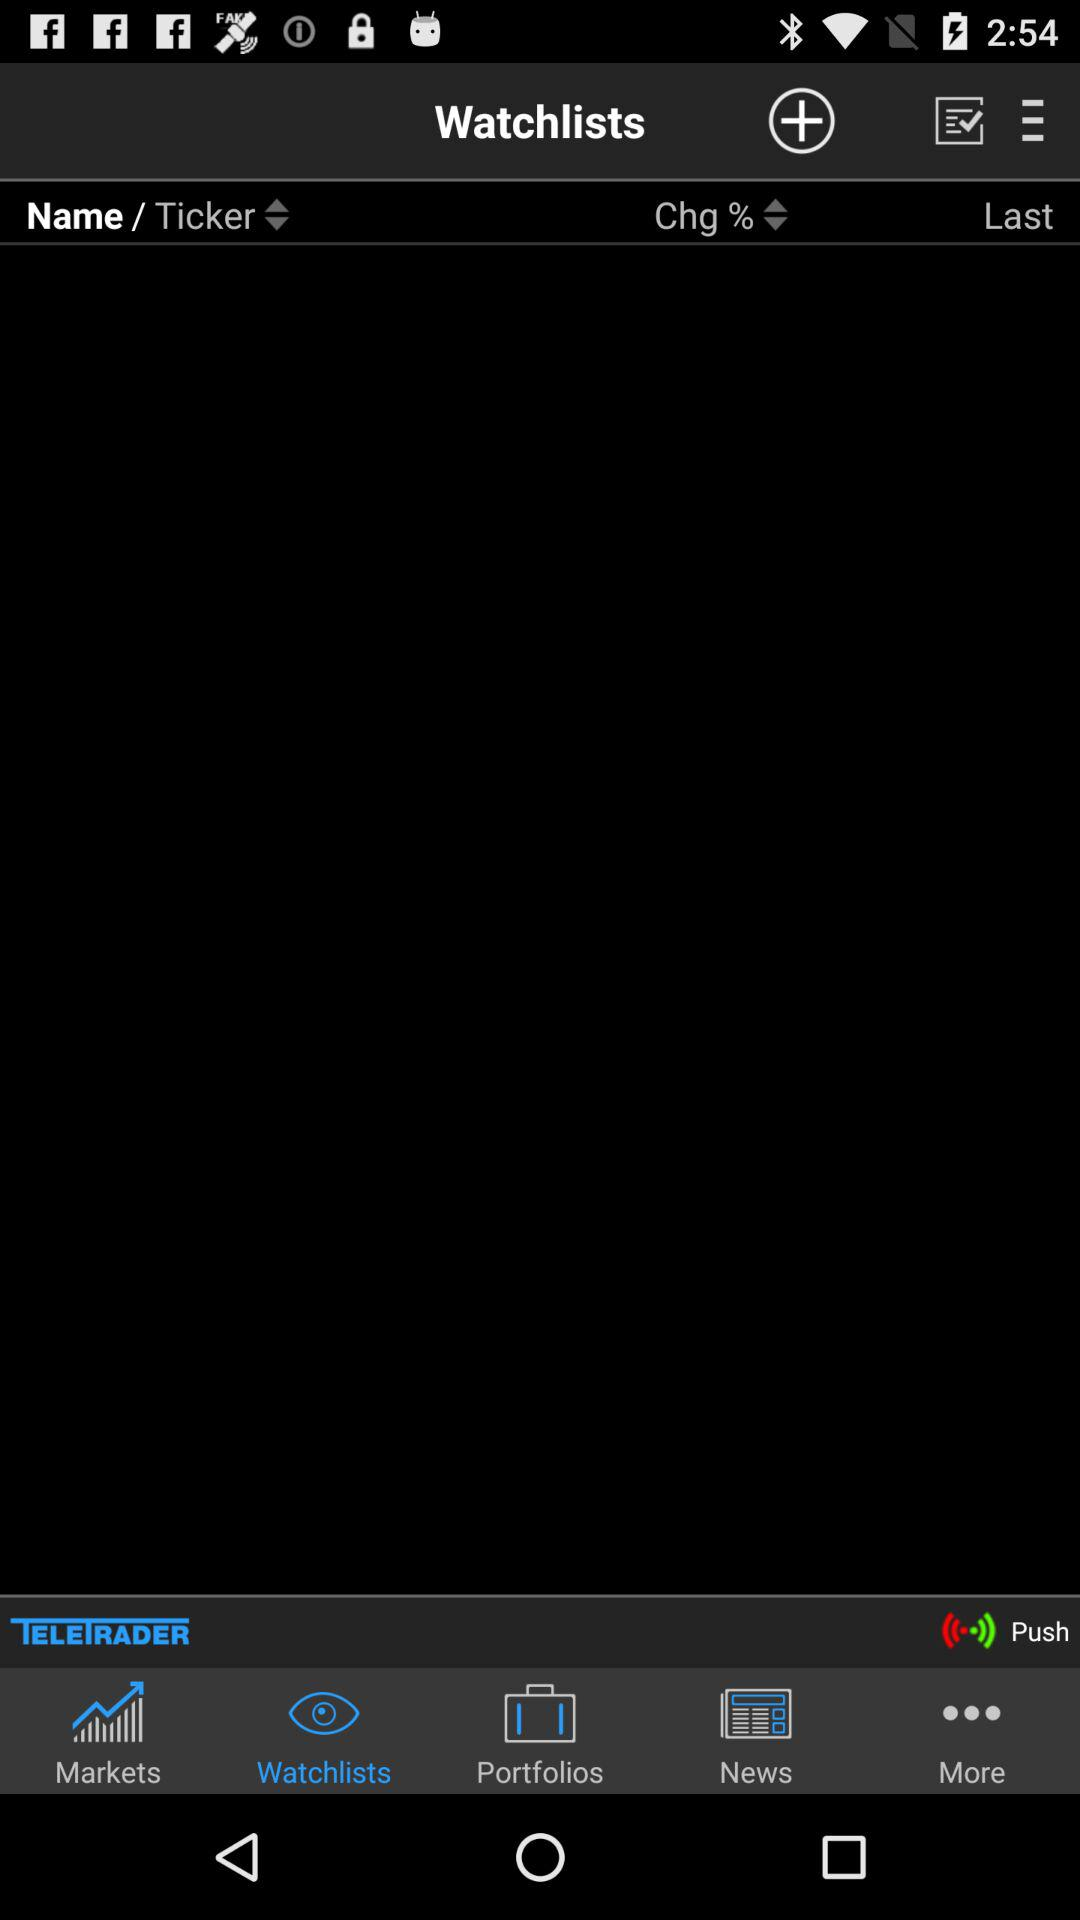Which news story made the headline?
When the provided information is insufficient, respond with <no answer>. <no answer> 